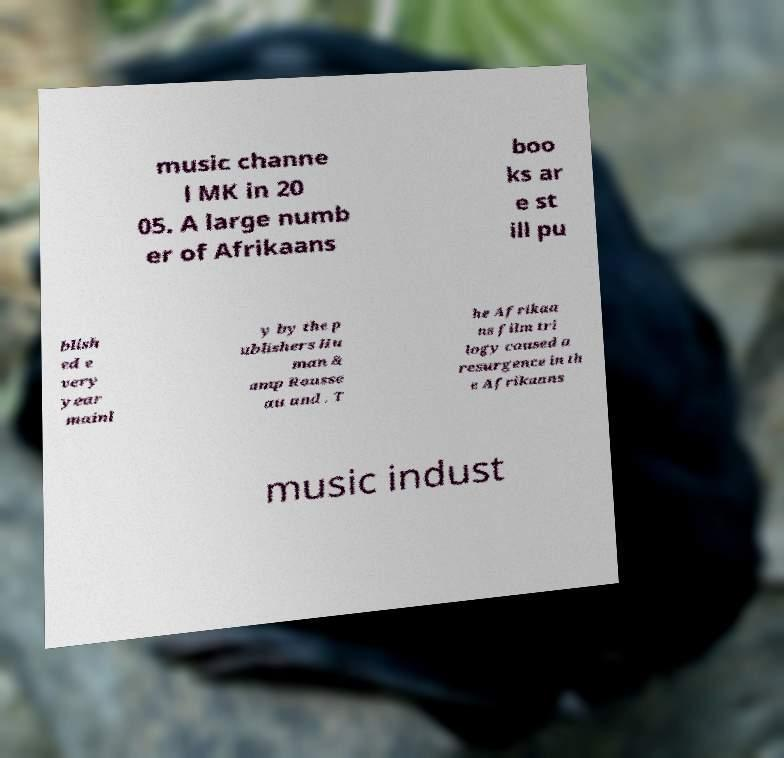For documentation purposes, I need the text within this image transcribed. Could you provide that? music channe l MK in 20 05. A large numb er of Afrikaans boo ks ar e st ill pu blish ed e very year mainl y by the p ublishers Hu man & amp Rousse au and . T he Afrikaa ns film tri logy caused a resurgence in th e Afrikaans music indust 